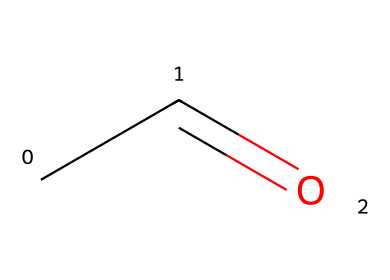What is the molecular formula of acetaldehyde? The SMILES representation "CC=O" indicates that there are two carbon atoms (C) and four hydrogen atoms (H) along with one oxygen atom (O). Therefore, the molecular formula can be deduced to be C2H4O.
Answer: C2H4O How many carbon atoms are present in acetaldehyde? The "CC" at the beginning of the SMILES indicates that there are two carbon atoms in acetaldehyde.
Answer: 2 What type of functional group is present in acetaldehyde? The "=" in "CC=O" signifies a carbonyl group (C=O), which is characteristic of aldehydes. Since it is at the end of the carbon chain, we can conclude that this compound is an aldehyde.
Answer: aldehyde What is the total number of hydrogen atoms in acetaldehyde? Analyzing "CC=O", each carbon is bound to the corresponding number of hydrogen atoms: the first carbon has three hydrogen atoms attached (as it's a terminal carbon) and the second carbon has one hydrogen atom (since it is attached to the carbonyl group). Thus, there are a total of four hydrogen atoms.
Answer: 4 Which part of the molecule determines its classification as an aldehyde? The presence of the carbonyl group (C=O) at the terminal position of the carbon chain, as indicated by the "=" sign in the SMILES representation, classifies it as an aldehyde.
Answer: carbonyl group What is the name of the chemical represented by this SMILES? The SMILES "CC=O" corresponds to acetaldehyde, which is the common name for the compound with this structure.
Answer: acetaldehyde 